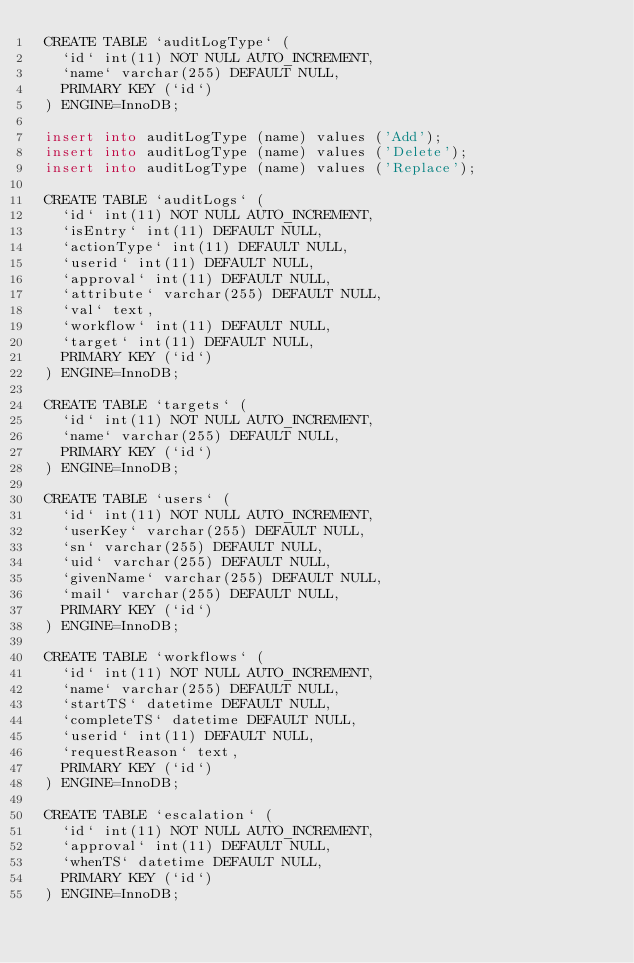<code> <loc_0><loc_0><loc_500><loc_500><_SQL_> CREATE TABLE `auditLogType` (
   `id` int(11) NOT NULL AUTO_INCREMENT,
   `name` varchar(255) DEFAULT NULL,
   PRIMARY KEY (`id`)
 ) ENGINE=InnoDB;
 
 insert into auditLogType (name) values ('Add');
 insert into auditLogType (name) values ('Delete');
 insert into auditLogType (name) values ('Replace');
 
 CREATE TABLE `auditLogs` (
   `id` int(11) NOT NULL AUTO_INCREMENT,
   `isEntry` int(11) DEFAULT NULL,
   `actionType` int(11) DEFAULT NULL,
   `userid` int(11) DEFAULT NULL,
   `approval` int(11) DEFAULT NULL,
   `attribute` varchar(255) DEFAULT NULL,
   `val` text,
   `workflow` int(11) DEFAULT NULL,
   `target` int(11) DEFAULT NULL,
   PRIMARY KEY (`id`)
 ) ENGINE=InnoDB;
 
 CREATE TABLE `targets` (
   `id` int(11) NOT NULL AUTO_INCREMENT,
   `name` varchar(255) DEFAULT NULL,
   PRIMARY KEY (`id`)
 ) ENGINE=InnoDB;
 
 CREATE TABLE `users` (
   `id` int(11) NOT NULL AUTO_INCREMENT,
   `userKey` varchar(255) DEFAULT NULL,
   `sn` varchar(255) DEFAULT NULL,
   `uid` varchar(255) DEFAULT NULL,
   `givenName` varchar(255) DEFAULT NULL,
   `mail` varchar(255) DEFAULT NULL,
   PRIMARY KEY (`id`)
 ) ENGINE=InnoDB;
 
 CREATE TABLE `workflows` (
   `id` int(11) NOT NULL AUTO_INCREMENT,
   `name` varchar(255) DEFAULT NULL,
   `startTS` datetime DEFAULT NULL,
   `completeTS` datetime DEFAULT NULL,
   `userid` int(11) DEFAULT NULL,
   `requestReason` text,
   PRIMARY KEY (`id`)
 ) ENGINE=InnoDB;
 
 CREATE TABLE `escalation` (
   `id` int(11) NOT NULL AUTO_INCREMENT,
   `approval` int(11) DEFAULT NULL,
   `whenTS` datetime DEFAULT NULL,
   PRIMARY KEY (`id`)
 ) ENGINE=InnoDB;

</code> 